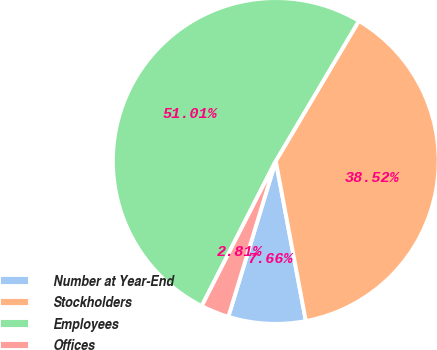<chart> <loc_0><loc_0><loc_500><loc_500><pie_chart><fcel>Number at Year-End<fcel>Stockholders<fcel>Employees<fcel>Offices<nl><fcel>7.66%<fcel>38.52%<fcel>51.0%<fcel>2.81%<nl></chart> 